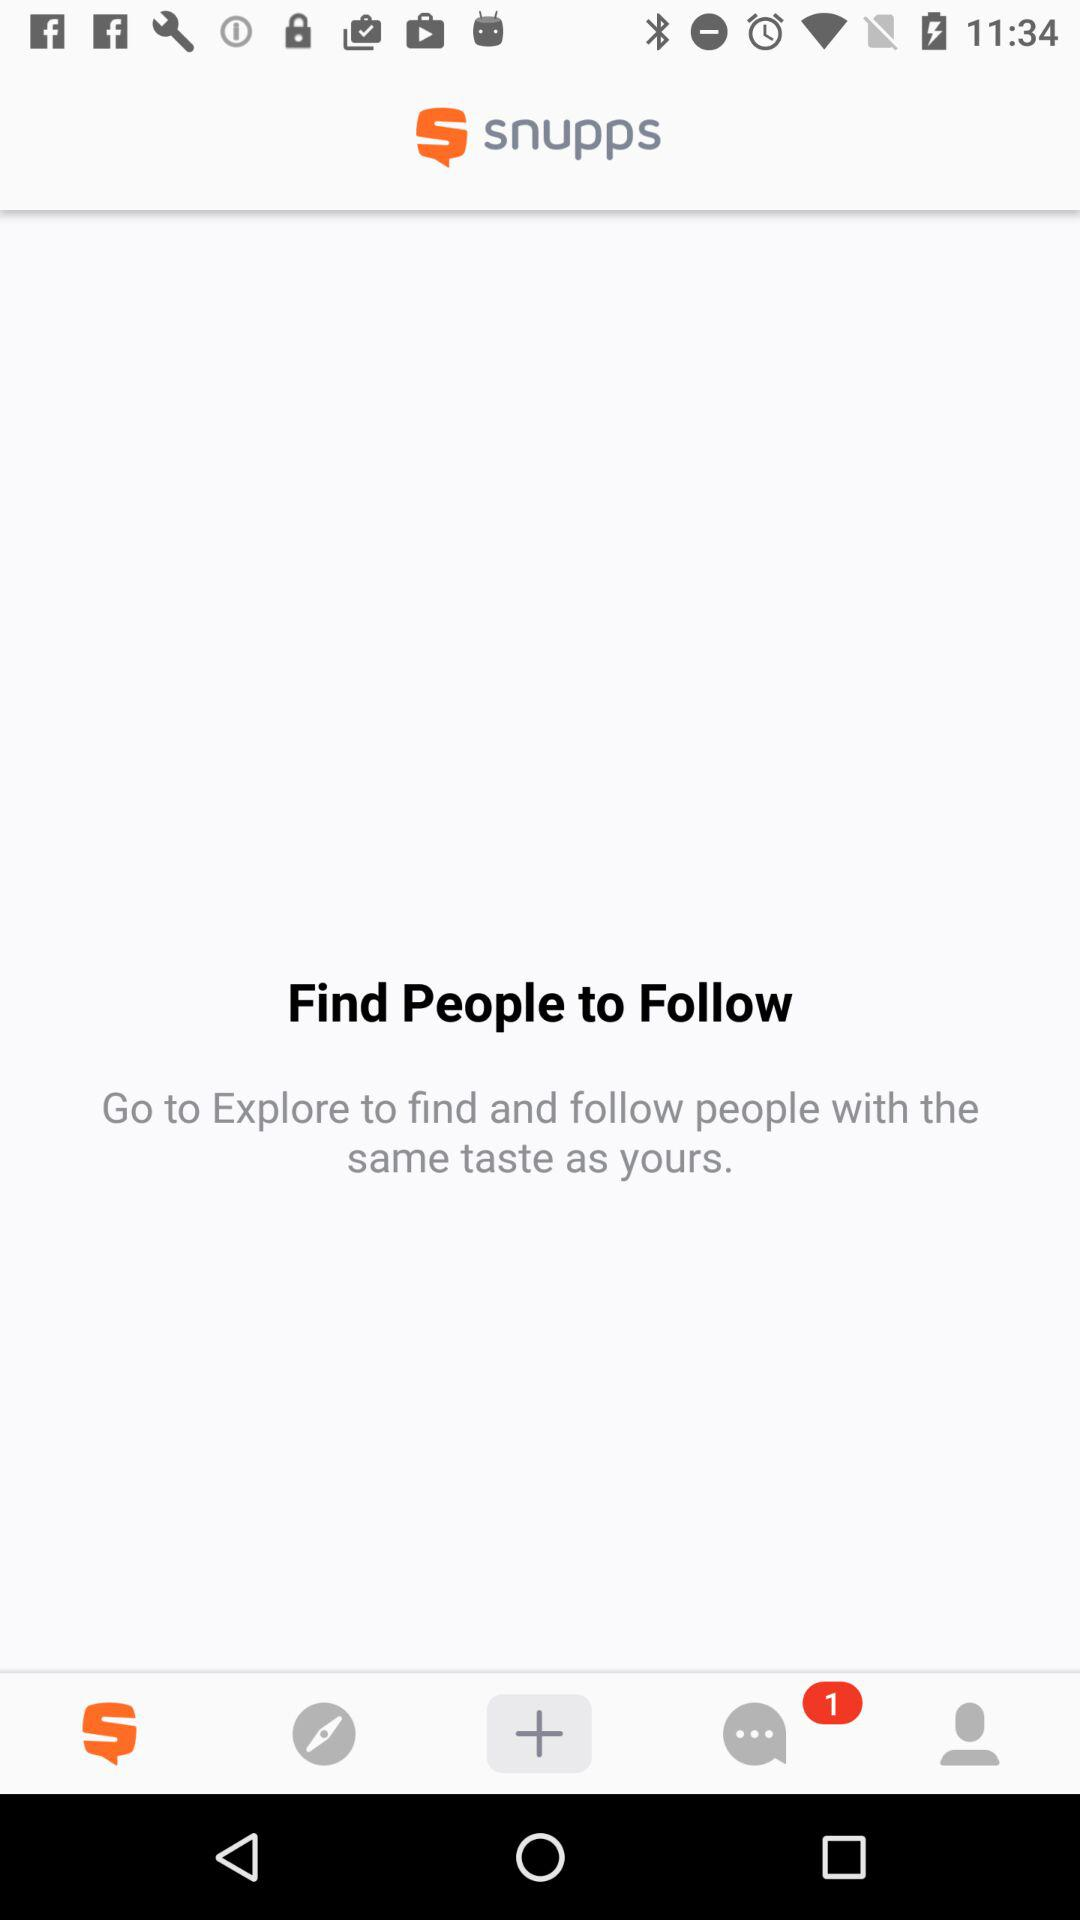How many message notifications are there? There is 1 message notification. 